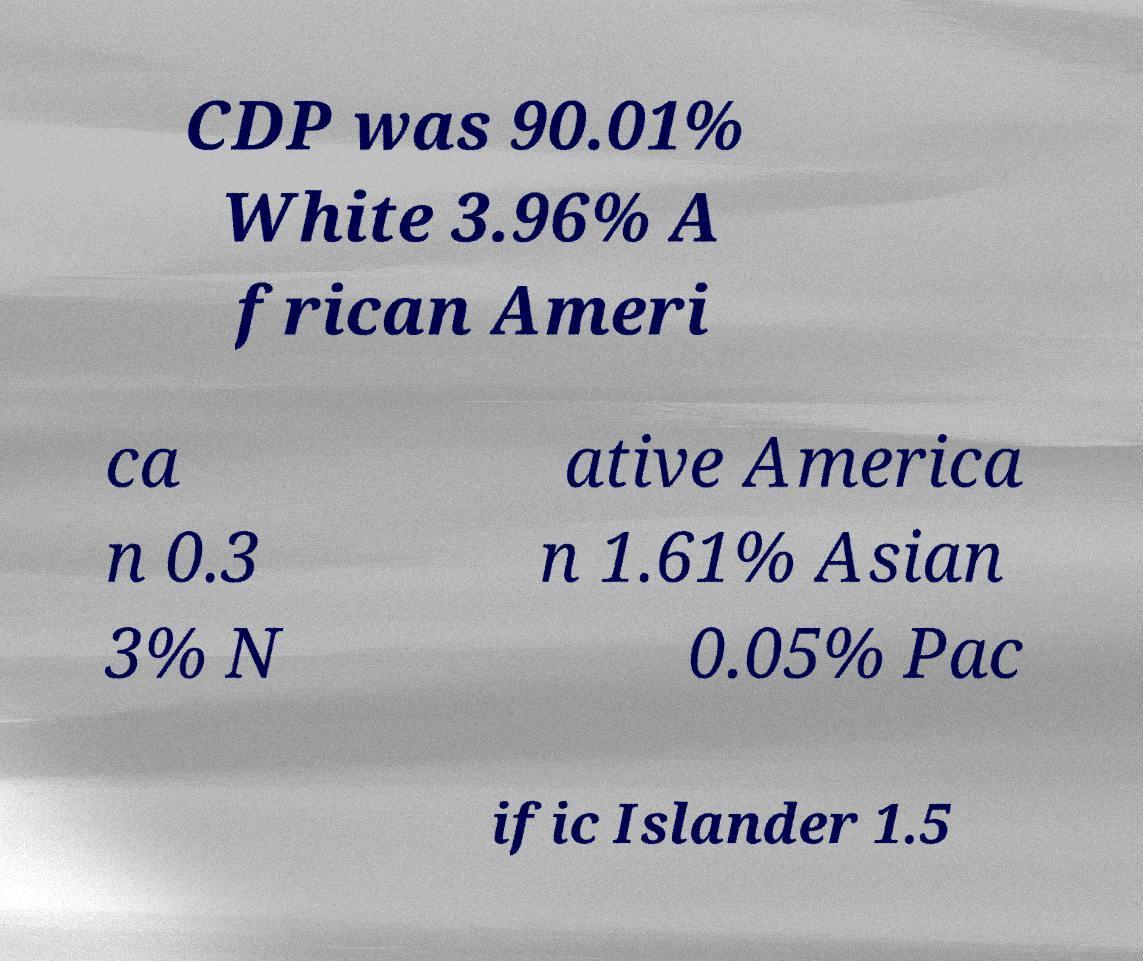Could you extract and type out the text from this image? CDP was 90.01% White 3.96% A frican Ameri ca n 0.3 3% N ative America n 1.61% Asian 0.05% Pac ific Islander 1.5 